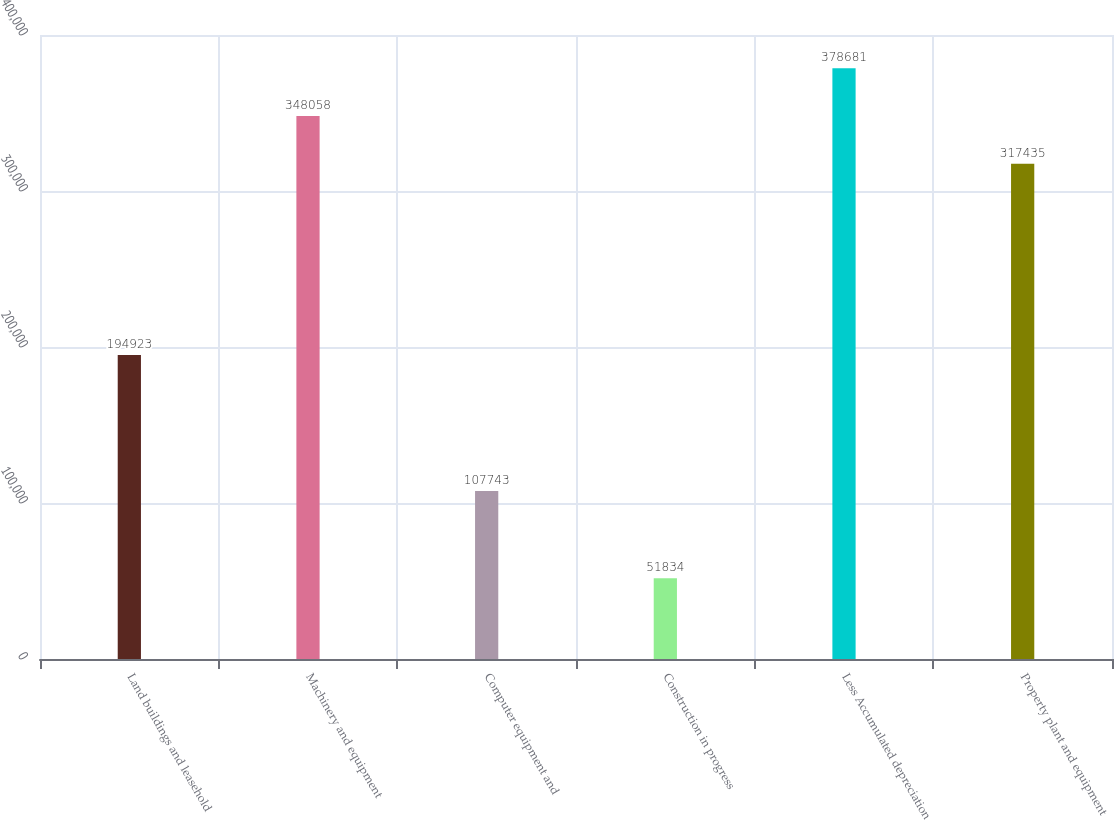Convert chart to OTSL. <chart><loc_0><loc_0><loc_500><loc_500><bar_chart><fcel>Land buildings and leasehold<fcel>Machinery and equipment<fcel>Computer equipment and<fcel>Construction in progress<fcel>Less Accumulated depreciation<fcel>Property plant and equipment<nl><fcel>194923<fcel>348058<fcel>107743<fcel>51834<fcel>378681<fcel>317435<nl></chart> 